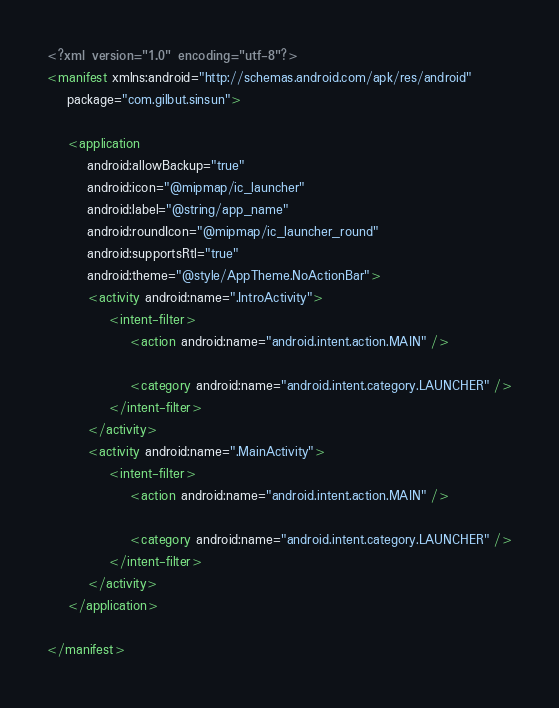Convert code to text. <code><loc_0><loc_0><loc_500><loc_500><_XML_><?xml version="1.0" encoding="utf-8"?>
<manifest xmlns:android="http://schemas.android.com/apk/res/android"
    package="com.gilbut.sinsun">

    <application
        android:allowBackup="true"
        android:icon="@mipmap/ic_launcher"
        android:label="@string/app_name"
        android:roundIcon="@mipmap/ic_launcher_round"
        android:supportsRtl="true"
        android:theme="@style/AppTheme.NoActionBar">
        <activity android:name=".IntroActivity">
            <intent-filter>
                <action android:name="android.intent.action.MAIN" />

                <category android:name="android.intent.category.LAUNCHER" />
            </intent-filter>
        </activity>
        <activity android:name=".MainActivity">
            <intent-filter>
                <action android:name="android.intent.action.MAIN" />

                <category android:name="android.intent.category.LAUNCHER" />
            </intent-filter>
        </activity>
    </application>

</manifest>
</code> 